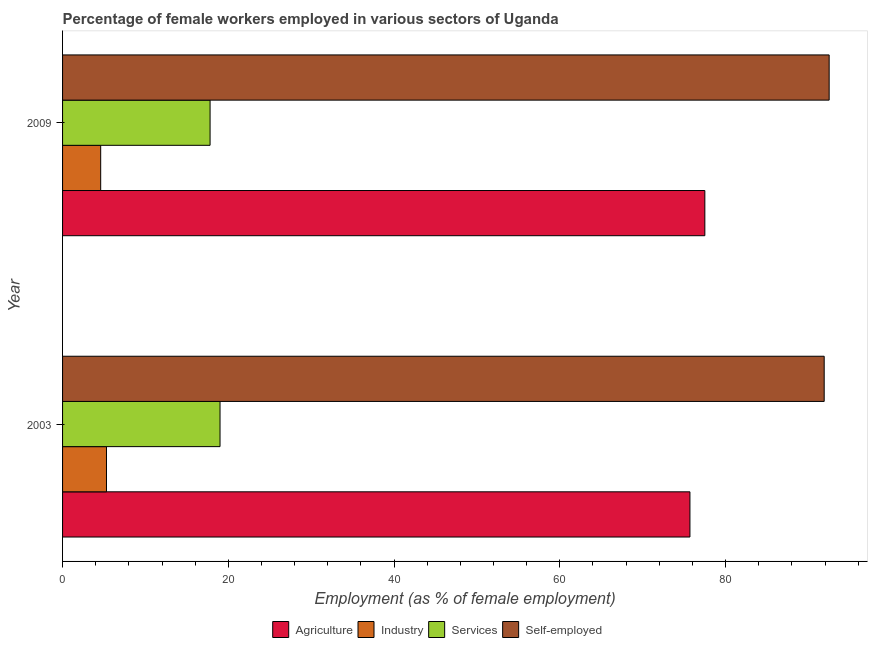How many groups of bars are there?
Your response must be concise. 2. Are the number of bars per tick equal to the number of legend labels?
Offer a terse response. Yes. How many bars are there on the 2nd tick from the bottom?
Make the answer very short. 4. What is the percentage of female workers in industry in 2003?
Your answer should be compact. 5.3. Across all years, what is the maximum percentage of self employed female workers?
Ensure brevity in your answer.  92.5. Across all years, what is the minimum percentage of female workers in services?
Provide a short and direct response. 17.8. In which year was the percentage of female workers in agriculture minimum?
Offer a very short reply. 2003. What is the total percentage of female workers in industry in the graph?
Keep it short and to the point. 9.9. What is the difference between the percentage of female workers in agriculture in 2003 and the percentage of female workers in services in 2009?
Offer a very short reply. 57.9. What is the average percentage of female workers in industry per year?
Provide a succinct answer. 4.95. In the year 2003, what is the difference between the percentage of female workers in agriculture and percentage of female workers in industry?
Offer a terse response. 70.4. In how many years, is the percentage of female workers in agriculture greater than 16 %?
Provide a succinct answer. 2. Is the percentage of self employed female workers in 2003 less than that in 2009?
Provide a short and direct response. Yes. In how many years, is the percentage of self employed female workers greater than the average percentage of self employed female workers taken over all years?
Offer a terse response. 1. What does the 1st bar from the top in 2003 represents?
Keep it short and to the point. Self-employed. What does the 3rd bar from the bottom in 2003 represents?
Give a very brief answer. Services. How many bars are there?
Ensure brevity in your answer.  8. Does the graph contain any zero values?
Your response must be concise. No. Where does the legend appear in the graph?
Provide a short and direct response. Bottom center. How are the legend labels stacked?
Your answer should be very brief. Horizontal. What is the title of the graph?
Give a very brief answer. Percentage of female workers employed in various sectors of Uganda. What is the label or title of the X-axis?
Keep it short and to the point. Employment (as % of female employment). What is the Employment (as % of female employment) of Agriculture in 2003?
Offer a very short reply. 75.7. What is the Employment (as % of female employment) in Industry in 2003?
Your answer should be compact. 5.3. What is the Employment (as % of female employment) of Self-employed in 2003?
Provide a short and direct response. 91.9. What is the Employment (as % of female employment) of Agriculture in 2009?
Give a very brief answer. 77.5. What is the Employment (as % of female employment) in Industry in 2009?
Offer a very short reply. 4.6. What is the Employment (as % of female employment) in Services in 2009?
Give a very brief answer. 17.8. What is the Employment (as % of female employment) of Self-employed in 2009?
Offer a very short reply. 92.5. Across all years, what is the maximum Employment (as % of female employment) of Agriculture?
Your answer should be very brief. 77.5. Across all years, what is the maximum Employment (as % of female employment) in Industry?
Offer a very short reply. 5.3. Across all years, what is the maximum Employment (as % of female employment) of Services?
Offer a very short reply. 19. Across all years, what is the maximum Employment (as % of female employment) of Self-employed?
Keep it short and to the point. 92.5. Across all years, what is the minimum Employment (as % of female employment) of Agriculture?
Provide a succinct answer. 75.7. Across all years, what is the minimum Employment (as % of female employment) in Industry?
Give a very brief answer. 4.6. Across all years, what is the minimum Employment (as % of female employment) in Services?
Your response must be concise. 17.8. Across all years, what is the minimum Employment (as % of female employment) in Self-employed?
Provide a succinct answer. 91.9. What is the total Employment (as % of female employment) in Agriculture in the graph?
Make the answer very short. 153.2. What is the total Employment (as % of female employment) in Industry in the graph?
Offer a terse response. 9.9. What is the total Employment (as % of female employment) of Services in the graph?
Provide a short and direct response. 36.8. What is the total Employment (as % of female employment) of Self-employed in the graph?
Ensure brevity in your answer.  184.4. What is the difference between the Employment (as % of female employment) of Services in 2003 and that in 2009?
Make the answer very short. 1.2. What is the difference between the Employment (as % of female employment) of Self-employed in 2003 and that in 2009?
Offer a very short reply. -0.6. What is the difference between the Employment (as % of female employment) in Agriculture in 2003 and the Employment (as % of female employment) in Industry in 2009?
Provide a short and direct response. 71.1. What is the difference between the Employment (as % of female employment) of Agriculture in 2003 and the Employment (as % of female employment) of Services in 2009?
Your response must be concise. 57.9. What is the difference between the Employment (as % of female employment) of Agriculture in 2003 and the Employment (as % of female employment) of Self-employed in 2009?
Offer a very short reply. -16.8. What is the difference between the Employment (as % of female employment) of Industry in 2003 and the Employment (as % of female employment) of Self-employed in 2009?
Give a very brief answer. -87.2. What is the difference between the Employment (as % of female employment) in Services in 2003 and the Employment (as % of female employment) in Self-employed in 2009?
Your answer should be compact. -73.5. What is the average Employment (as % of female employment) in Agriculture per year?
Offer a terse response. 76.6. What is the average Employment (as % of female employment) of Industry per year?
Offer a terse response. 4.95. What is the average Employment (as % of female employment) of Services per year?
Give a very brief answer. 18.4. What is the average Employment (as % of female employment) in Self-employed per year?
Ensure brevity in your answer.  92.2. In the year 2003, what is the difference between the Employment (as % of female employment) in Agriculture and Employment (as % of female employment) in Industry?
Offer a terse response. 70.4. In the year 2003, what is the difference between the Employment (as % of female employment) of Agriculture and Employment (as % of female employment) of Services?
Keep it short and to the point. 56.7. In the year 2003, what is the difference between the Employment (as % of female employment) in Agriculture and Employment (as % of female employment) in Self-employed?
Provide a succinct answer. -16.2. In the year 2003, what is the difference between the Employment (as % of female employment) of Industry and Employment (as % of female employment) of Services?
Keep it short and to the point. -13.7. In the year 2003, what is the difference between the Employment (as % of female employment) of Industry and Employment (as % of female employment) of Self-employed?
Ensure brevity in your answer.  -86.6. In the year 2003, what is the difference between the Employment (as % of female employment) in Services and Employment (as % of female employment) in Self-employed?
Offer a terse response. -72.9. In the year 2009, what is the difference between the Employment (as % of female employment) in Agriculture and Employment (as % of female employment) in Industry?
Give a very brief answer. 72.9. In the year 2009, what is the difference between the Employment (as % of female employment) of Agriculture and Employment (as % of female employment) of Services?
Provide a succinct answer. 59.7. In the year 2009, what is the difference between the Employment (as % of female employment) in Industry and Employment (as % of female employment) in Self-employed?
Offer a very short reply. -87.9. In the year 2009, what is the difference between the Employment (as % of female employment) in Services and Employment (as % of female employment) in Self-employed?
Offer a very short reply. -74.7. What is the ratio of the Employment (as % of female employment) in Agriculture in 2003 to that in 2009?
Offer a very short reply. 0.98. What is the ratio of the Employment (as % of female employment) in Industry in 2003 to that in 2009?
Your response must be concise. 1.15. What is the ratio of the Employment (as % of female employment) in Services in 2003 to that in 2009?
Your answer should be compact. 1.07. What is the ratio of the Employment (as % of female employment) in Self-employed in 2003 to that in 2009?
Your answer should be compact. 0.99. What is the difference between the highest and the second highest Employment (as % of female employment) in Agriculture?
Provide a short and direct response. 1.8. What is the difference between the highest and the second highest Employment (as % of female employment) in Industry?
Keep it short and to the point. 0.7. What is the difference between the highest and the second highest Employment (as % of female employment) in Services?
Keep it short and to the point. 1.2. What is the difference between the highest and the lowest Employment (as % of female employment) of Agriculture?
Provide a succinct answer. 1.8. What is the difference between the highest and the lowest Employment (as % of female employment) of Industry?
Your response must be concise. 0.7. What is the difference between the highest and the lowest Employment (as % of female employment) in Services?
Provide a short and direct response. 1.2. What is the difference between the highest and the lowest Employment (as % of female employment) in Self-employed?
Offer a very short reply. 0.6. 